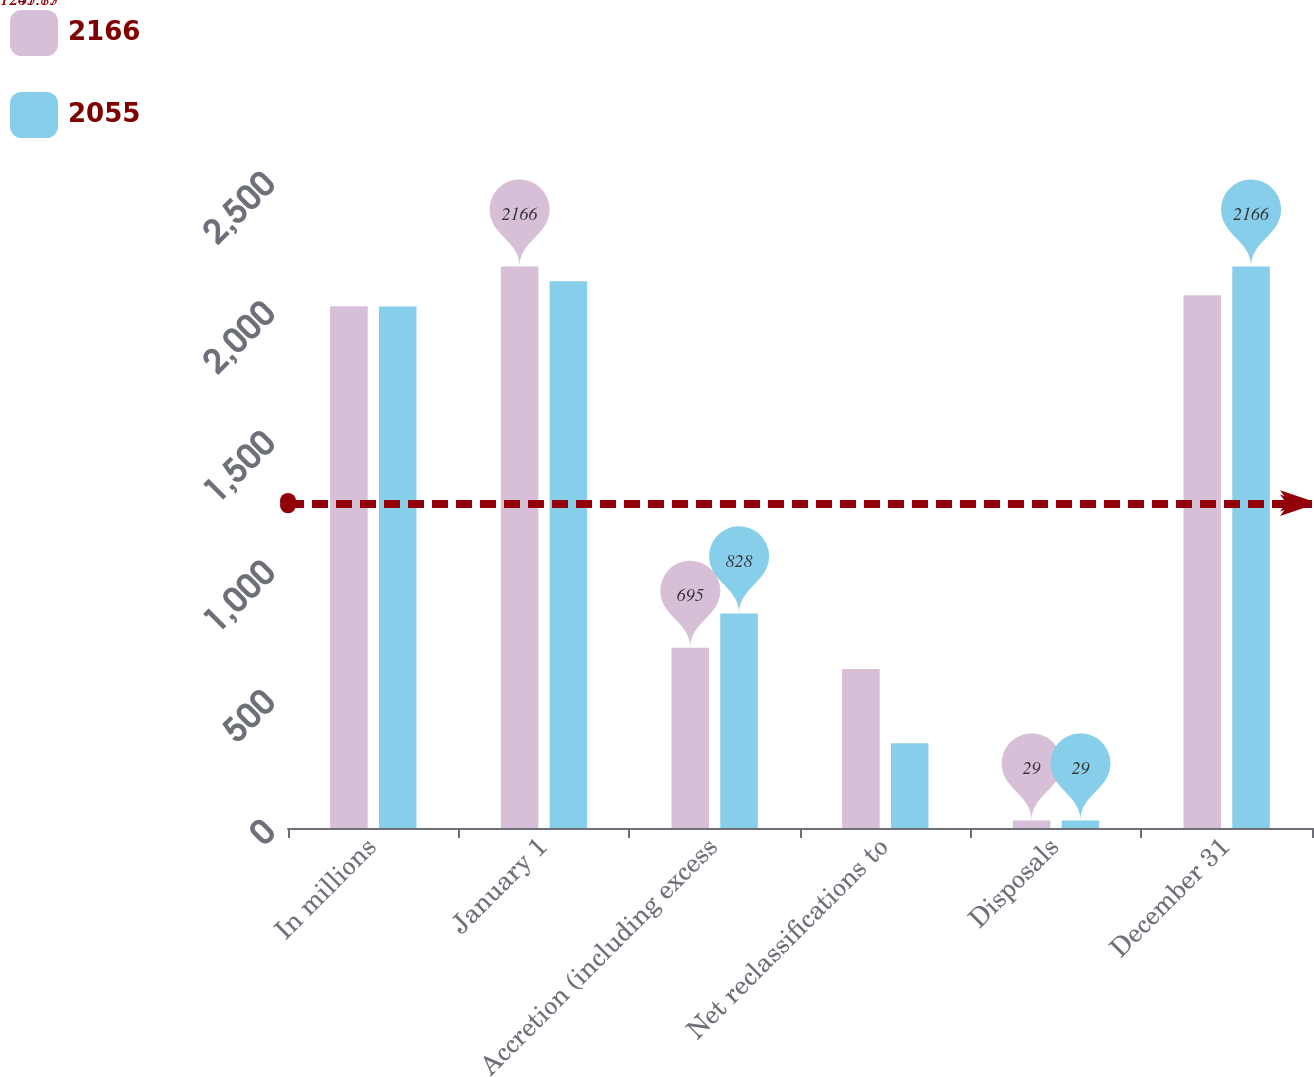Convert chart. <chart><loc_0><loc_0><loc_500><loc_500><stacked_bar_chart><ecel><fcel>In millions<fcel>January 1<fcel>Accretion (including excess<fcel>Net reclassifications to<fcel>Disposals<fcel>December 31<nl><fcel>2166<fcel>2013<fcel>2166<fcel>695<fcel>613<fcel>29<fcel>2055<nl><fcel>2055<fcel>2012<fcel>2109<fcel>828<fcel>327<fcel>29<fcel>2166<nl></chart> 